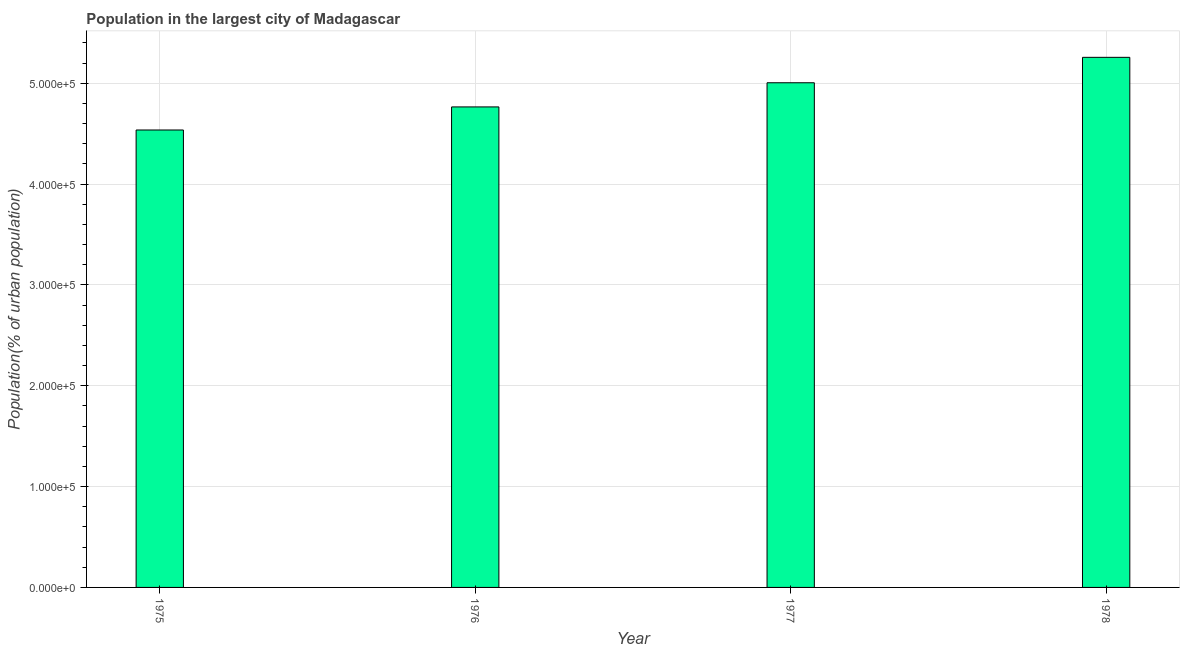Does the graph contain any zero values?
Offer a terse response. No. What is the title of the graph?
Provide a short and direct response. Population in the largest city of Madagascar. What is the label or title of the Y-axis?
Your answer should be very brief. Population(% of urban population). What is the population in largest city in 1976?
Keep it short and to the point. 4.77e+05. Across all years, what is the maximum population in largest city?
Provide a short and direct response. 5.26e+05. Across all years, what is the minimum population in largest city?
Keep it short and to the point. 4.54e+05. In which year was the population in largest city maximum?
Your response must be concise. 1978. In which year was the population in largest city minimum?
Your answer should be compact. 1975. What is the sum of the population in largest city?
Your answer should be compact. 1.96e+06. What is the difference between the population in largest city in 1976 and 1978?
Give a very brief answer. -4.92e+04. What is the average population in largest city per year?
Your answer should be compact. 4.89e+05. What is the median population in largest city?
Offer a very short reply. 4.89e+05. In how many years, is the population in largest city greater than 520000 %?
Your response must be concise. 1. What is the ratio of the population in largest city in 1975 to that in 1976?
Offer a very short reply. 0.95. Is the population in largest city in 1976 less than that in 1977?
Provide a succinct answer. Yes. Is the difference between the population in largest city in 1977 and 1978 greater than the difference between any two years?
Your answer should be very brief. No. What is the difference between the highest and the second highest population in largest city?
Your response must be concise. 2.52e+04. What is the difference between the highest and the lowest population in largest city?
Make the answer very short. 7.21e+04. In how many years, is the population in largest city greater than the average population in largest city taken over all years?
Your answer should be compact. 2. How many bars are there?
Your answer should be very brief. 4. How many years are there in the graph?
Your answer should be compact. 4. What is the difference between two consecutive major ticks on the Y-axis?
Your response must be concise. 1.00e+05. What is the Population(% of urban population) of 1975?
Offer a very short reply. 4.54e+05. What is the Population(% of urban population) in 1976?
Offer a very short reply. 4.77e+05. What is the Population(% of urban population) of 1977?
Your answer should be very brief. 5.00e+05. What is the Population(% of urban population) in 1978?
Keep it short and to the point. 5.26e+05. What is the difference between the Population(% of urban population) in 1975 and 1976?
Offer a terse response. -2.29e+04. What is the difference between the Population(% of urban population) in 1975 and 1977?
Your answer should be compact. -4.69e+04. What is the difference between the Population(% of urban population) in 1975 and 1978?
Provide a succinct answer. -7.21e+04. What is the difference between the Population(% of urban population) in 1976 and 1977?
Your response must be concise. -2.40e+04. What is the difference between the Population(% of urban population) in 1976 and 1978?
Give a very brief answer. -4.92e+04. What is the difference between the Population(% of urban population) in 1977 and 1978?
Your response must be concise. -2.52e+04. What is the ratio of the Population(% of urban population) in 1975 to that in 1976?
Offer a very short reply. 0.95. What is the ratio of the Population(% of urban population) in 1975 to that in 1977?
Give a very brief answer. 0.91. What is the ratio of the Population(% of urban population) in 1975 to that in 1978?
Your answer should be very brief. 0.86. What is the ratio of the Population(% of urban population) in 1976 to that in 1978?
Provide a short and direct response. 0.91. 